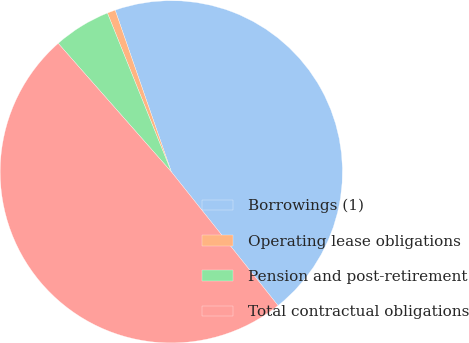<chart> <loc_0><loc_0><loc_500><loc_500><pie_chart><fcel>Borrowings (1)<fcel>Operating lease obligations<fcel>Pension and post-retirement<fcel>Total contractual obligations<nl><fcel>44.6%<fcel>0.77%<fcel>5.4%<fcel>49.23%<nl></chart> 